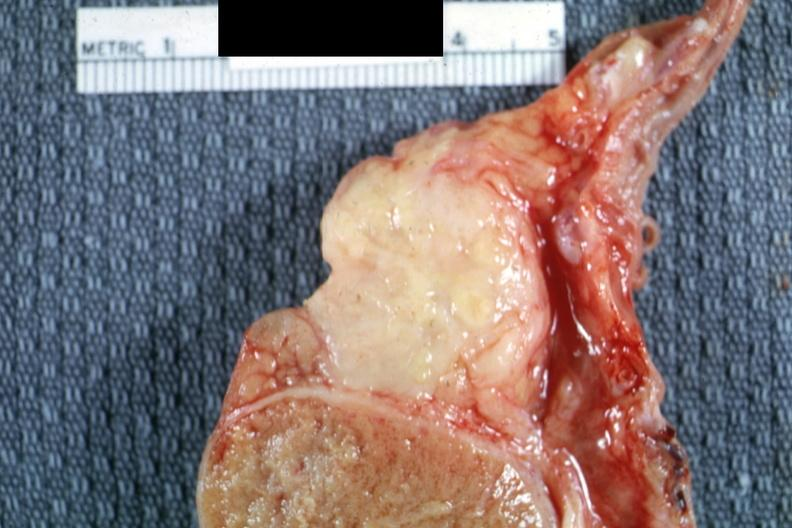what is present?
Answer the question using a single word or phrase. Tuberculosis 